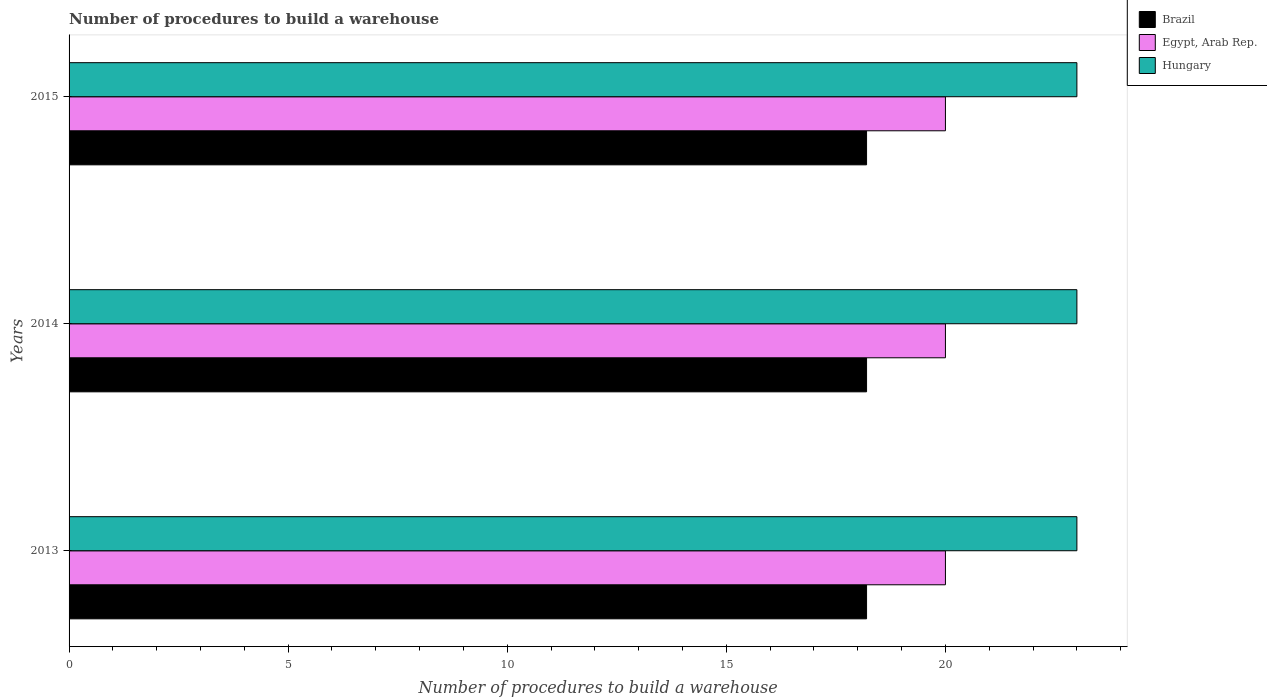How many groups of bars are there?
Provide a short and direct response. 3. Are the number of bars on each tick of the Y-axis equal?
Give a very brief answer. Yes. How many bars are there on the 1st tick from the top?
Your response must be concise. 3. How many bars are there on the 1st tick from the bottom?
Your response must be concise. 3. What is the label of the 2nd group of bars from the top?
Keep it short and to the point. 2014. What is the number of procedures to build a warehouse in in Hungary in 2013?
Your answer should be very brief. 23. Across all years, what is the maximum number of procedures to build a warehouse in in Egypt, Arab Rep.?
Make the answer very short. 20. Across all years, what is the minimum number of procedures to build a warehouse in in Brazil?
Offer a very short reply. 18.2. In which year was the number of procedures to build a warehouse in in Egypt, Arab Rep. maximum?
Ensure brevity in your answer.  2013. What is the total number of procedures to build a warehouse in in Hungary in the graph?
Give a very brief answer. 69. What is the difference between the number of procedures to build a warehouse in in Brazil in 2013 and that in 2015?
Your answer should be compact. 0. What is the difference between the number of procedures to build a warehouse in in Hungary in 2013 and the number of procedures to build a warehouse in in Egypt, Arab Rep. in 2015?
Offer a terse response. 3. In the year 2015, what is the difference between the number of procedures to build a warehouse in in Egypt, Arab Rep. and number of procedures to build a warehouse in in Hungary?
Offer a terse response. -3. What is the ratio of the number of procedures to build a warehouse in in Hungary in 2014 to that in 2015?
Your answer should be compact. 1. Is the difference between the number of procedures to build a warehouse in in Egypt, Arab Rep. in 2013 and 2015 greater than the difference between the number of procedures to build a warehouse in in Hungary in 2013 and 2015?
Keep it short and to the point. No. What is the difference between the highest and the second highest number of procedures to build a warehouse in in Egypt, Arab Rep.?
Keep it short and to the point. 0. What is the difference between the highest and the lowest number of procedures to build a warehouse in in Egypt, Arab Rep.?
Offer a terse response. 0. In how many years, is the number of procedures to build a warehouse in in Hungary greater than the average number of procedures to build a warehouse in in Hungary taken over all years?
Keep it short and to the point. 0. Is the sum of the number of procedures to build a warehouse in in Hungary in 2013 and 2015 greater than the maximum number of procedures to build a warehouse in in Egypt, Arab Rep. across all years?
Provide a short and direct response. Yes. What does the 2nd bar from the top in 2015 represents?
Offer a terse response. Egypt, Arab Rep. What does the 2nd bar from the bottom in 2013 represents?
Your answer should be compact. Egypt, Arab Rep. How many bars are there?
Your answer should be very brief. 9. Are all the bars in the graph horizontal?
Ensure brevity in your answer.  Yes. Are the values on the major ticks of X-axis written in scientific E-notation?
Provide a succinct answer. No. Does the graph contain grids?
Ensure brevity in your answer.  No. Where does the legend appear in the graph?
Keep it short and to the point. Top right. What is the title of the graph?
Your response must be concise. Number of procedures to build a warehouse. Does "Timor-Leste" appear as one of the legend labels in the graph?
Ensure brevity in your answer.  No. What is the label or title of the X-axis?
Offer a very short reply. Number of procedures to build a warehouse. What is the label or title of the Y-axis?
Your answer should be very brief. Years. What is the Number of procedures to build a warehouse of Hungary in 2013?
Your answer should be very brief. 23. What is the Number of procedures to build a warehouse in Brazil in 2014?
Offer a terse response. 18.2. What is the Number of procedures to build a warehouse of Hungary in 2014?
Keep it short and to the point. 23. What is the Number of procedures to build a warehouse in Brazil in 2015?
Your answer should be very brief. 18.2. Across all years, what is the maximum Number of procedures to build a warehouse in Egypt, Arab Rep.?
Give a very brief answer. 20. Across all years, what is the maximum Number of procedures to build a warehouse in Hungary?
Provide a short and direct response. 23. Across all years, what is the minimum Number of procedures to build a warehouse in Egypt, Arab Rep.?
Offer a terse response. 20. Across all years, what is the minimum Number of procedures to build a warehouse in Hungary?
Your answer should be compact. 23. What is the total Number of procedures to build a warehouse in Brazil in the graph?
Your answer should be compact. 54.6. What is the total Number of procedures to build a warehouse in Hungary in the graph?
Make the answer very short. 69. What is the difference between the Number of procedures to build a warehouse of Brazil in 2013 and that in 2014?
Your answer should be very brief. 0. What is the difference between the Number of procedures to build a warehouse in Brazil in 2013 and that in 2015?
Provide a short and direct response. 0. What is the difference between the Number of procedures to build a warehouse of Hungary in 2014 and that in 2015?
Provide a succinct answer. 0. What is the difference between the Number of procedures to build a warehouse in Brazil in 2013 and the Number of procedures to build a warehouse in Hungary in 2014?
Provide a succinct answer. -4.8. What is the difference between the Number of procedures to build a warehouse of Egypt, Arab Rep. in 2013 and the Number of procedures to build a warehouse of Hungary in 2014?
Give a very brief answer. -3. What is the difference between the Number of procedures to build a warehouse in Egypt, Arab Rep. in 2013 and the Number of procedures to build a warehouse in Hungary in 2015?
Give a very brief answer. -3. What is the difference between the Number of procedures to build a warehouse in Brazil in 2014 and the Number of procedures to build a warehouse in Egypt, Arab Rep. in 2015?
Your answer should be compact. -1.8. What is the difference between the Number of procedures to build a warehouse in Egypt, Arab Rep. in 2014 and the Number of procedures to build a warehouse in Hungary in 2015?
Ensure brevity in your answer.  -3. What is the average Number of procedures to build a warehouse in Hungary per year?
Offer a very short reply. 23. In the year 2013, what is the difference between the Number of procedures to build a warehouse in Egypt, Arab Rep. and Number of procedures to build a warehouse in Hungary?
Your answer should be compact. -3. In the year 2014, what is the difference between the Number of procedures to build a warehouse of Egypt, Arab Rep. and Number of procedures to build a warehouse of Hungary?
Offer a terse response. -3. In the year 2015, what is the difference between the Number of procedures to build a warehouse in Brazil and Number of procedures to build a warehouse in Egypt, Arab Rep.?
Offer a terse response. -1.8. What is the ratio of the Number of procedures to build a warehouse in Brazil in 2013 to that in 2014?
Offer a terse response. 1. What is the ratio of the Number of procedures to build a warehouse of Brazil in 2013 to that in 2015?
Keep it short and to the point. 1. What is the ratio of the Number of procedures to build a warehouse in Egypt, Arab Rep. in 2014 to that in 2015?
Provide a succinct answer. 1. What is the difference between the highest and the second highest Number of procedures to build a warehouse of Brazil?
Provide a short and direct response. 0. What is the difference between the highest and the second highest Number of procedures to build a warehouse in Hungary?
Offer a terse response. 0. What is the difference between the highest and the lowest Number of procedures to build a warehouse in Egypt, Arab Rep.?
Give a very brief answer. 0. 